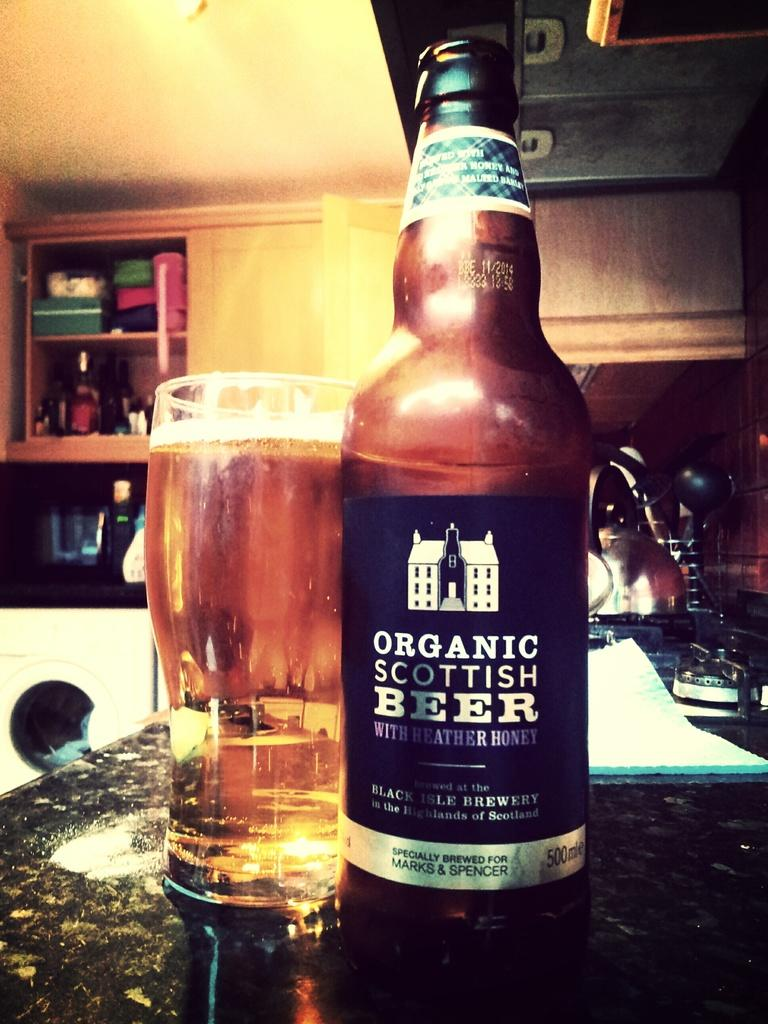What is placed on the table counter in the image? There is a beer bottle and a glass filled with a beverage on the table counter. What can be seen in the background of the image? There is a washing machine and cupboards in the background. What type of pain is the person experiencing in the image? There is no person present in the image, and therefore no indication of any pain being experienced. 